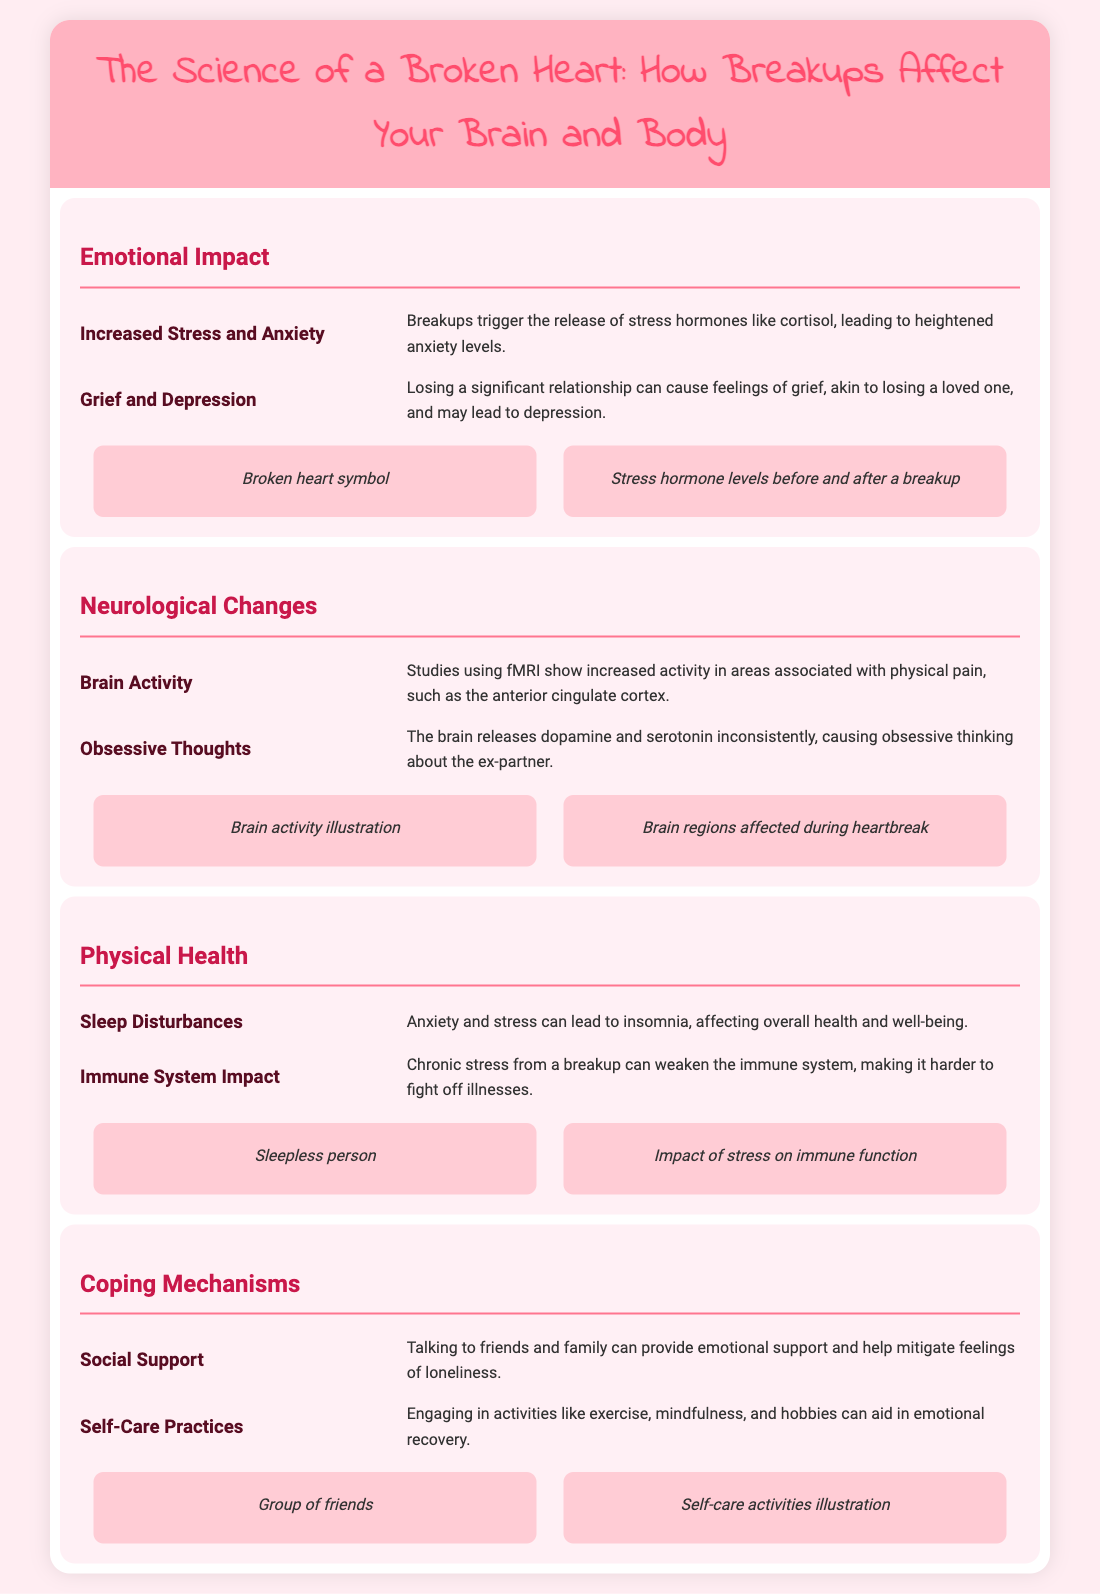what hormone is increased after a breakup? The document states that breakups trigger the release of stress hormones, specifically mentioning cortisol.
Answer: cortisol which brain area is associated with physical pain during heartbreak? The document mentions the anterior cingulate cortex as the brain area showing increased activity related to physical pain.
Answer: anterior cingulate cortex what negative effect on sleep can result from a breakup? The document indicates that anxiety and stress can lead to insomnia.
Answer: insomnia what physical health aspect is weakened by chronic stress? The document says that chronic stress from a breakup can weaken the immune system.
Answer: immune system what emotional support strategy is suggested for coping with a breakup? The document recommends talking to friends and family to provide emotional support.
Answer: social support how can self-care practices aid recovery? The document suggests that engaging in activities like exercise and mindfulness can aid in emotional recovery.
Answer: emotional recovery what imagery represents sleep disturbances? The document includes a visual icon of a sleepless person to represent sleep disturbances.
Answer: sleepless person what is the main focus of the infographic? The document discusses how breakups affect your brain and body, covering emotional, neurological, and physical health aspects.
Answer: breakups affect your brain and body 